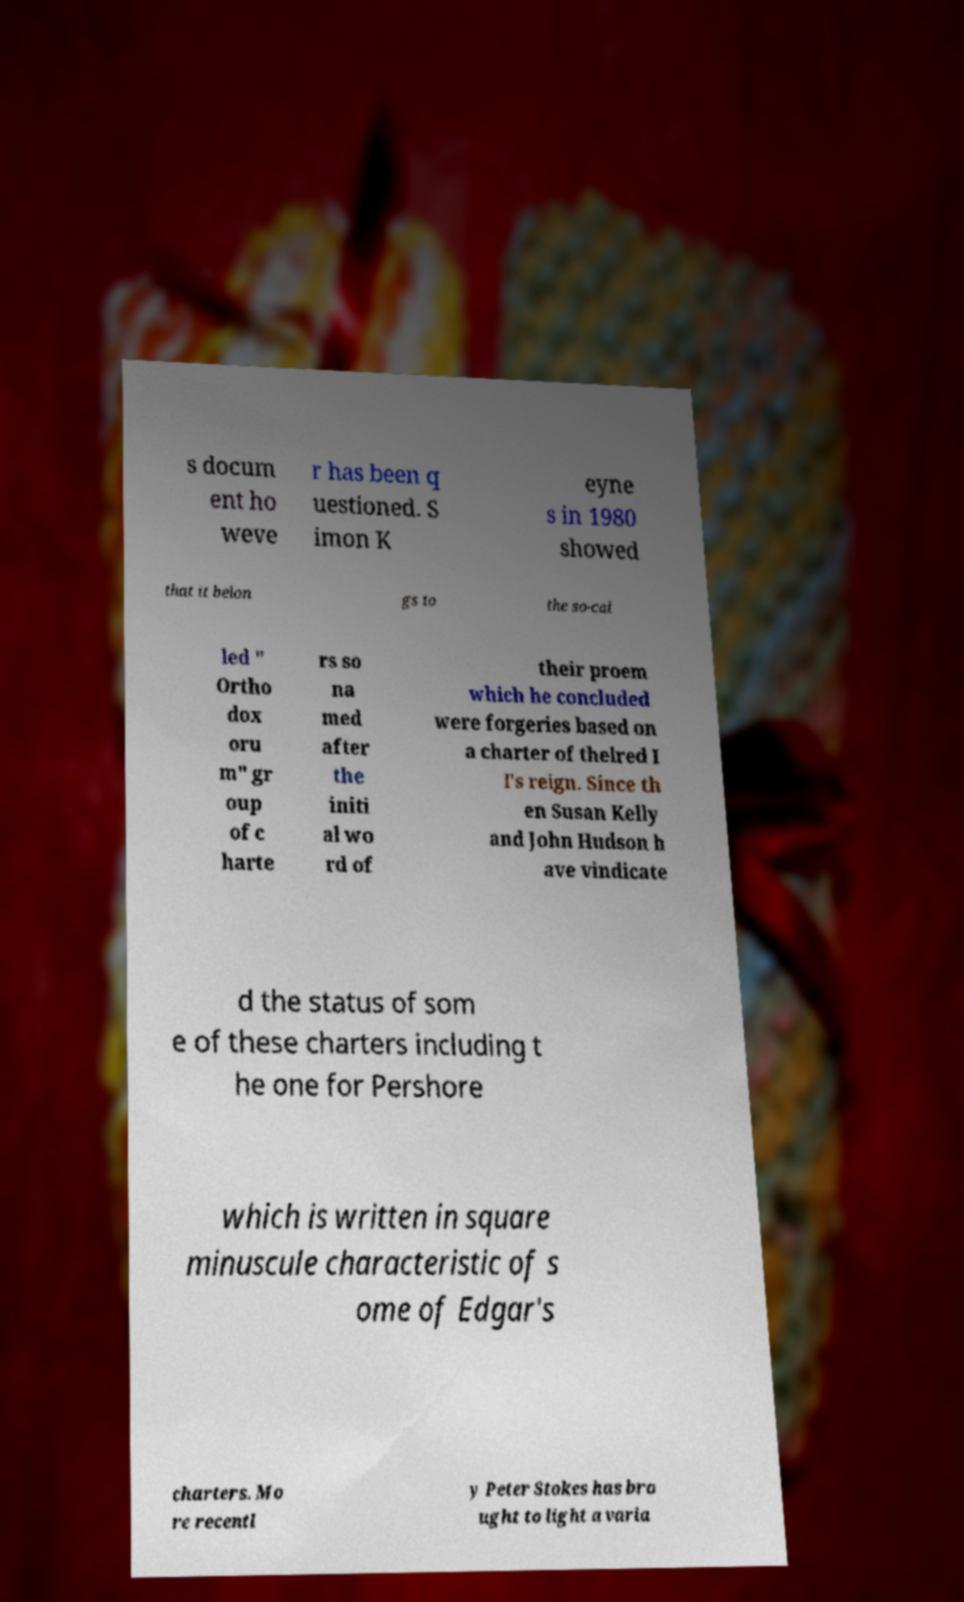What messages or text are displayed in this image? I need them in a readable, typed format. s docum ent ho weve r has been q uestioned. S imon K eyne s in 1980 showed that it belon gs to the so-cal led " Ortho dox oru m" gr oup of c harte rs so na med after the initi al wo rd of their proem which he concluded were forgeries based on a charter of thelred I I's reign. Since th en Susan Kelly and John Hudson h ave vindicate d the status of som e of these charters including t he one for Pershore which is written in square minuscule characteristic of s ome of Edgar's charters. Mo re recentl y Peter Stokes has bro ught to light a varia 